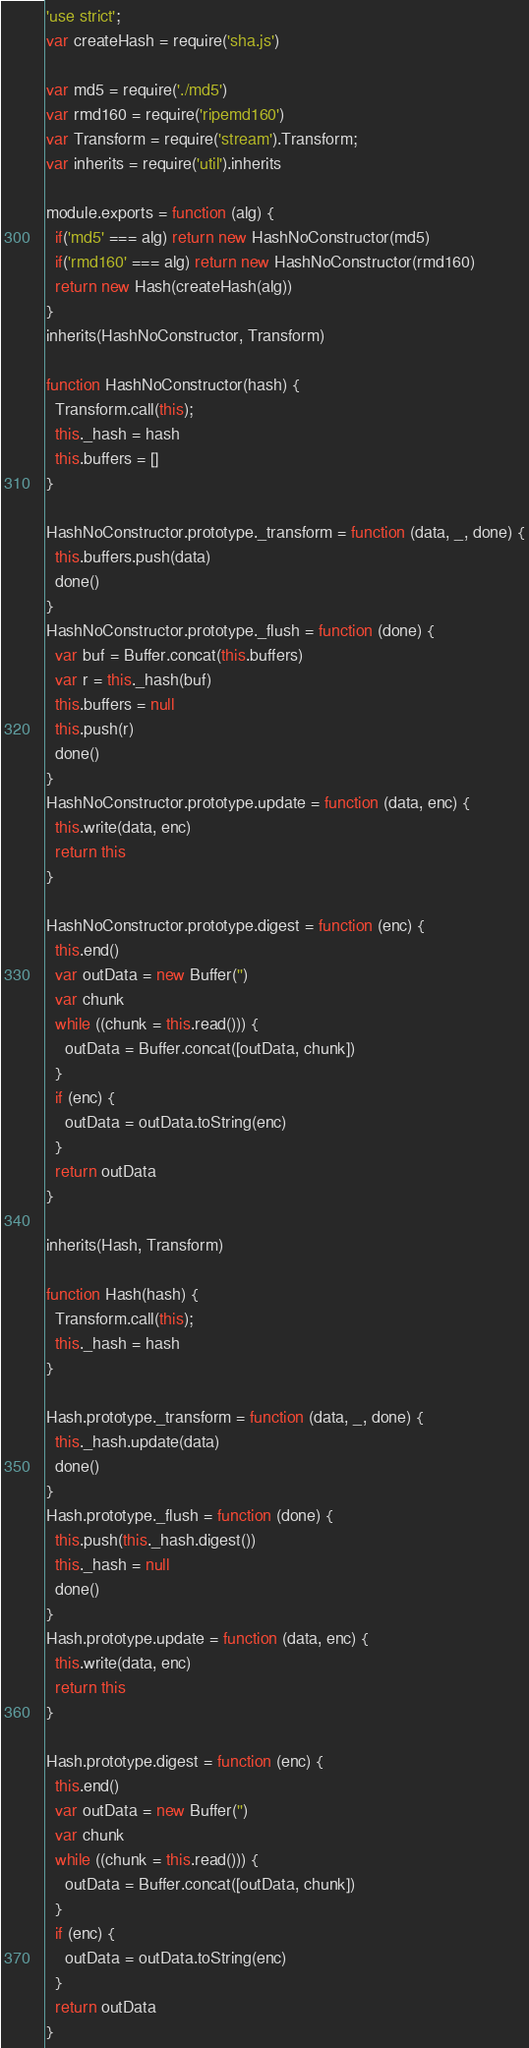Convert code to text. <code><loc_0><loc_0><loc_500><loc_500><_JavaScript_>'use strict';
var createHash = require('sha.js')

var md5 = require('./md5')
var rmd160 = require('ripemd160')
var Transform = require('stream').Transform;
var inherits = require('util').inherits

module.exports = function (alg) {
  if('md5' === alg) return new HashNoConstructor(md5)
  if('rmd160' === alg) return new HashNoConstructor(rmd160)
  return new Hash(createHash(alg))
}
inherits(HashNoConstructor, Transform)

function HashNoConstructor(hash) {
  Transform.call(this);
  this._hash = hash
  this.buffers = []
}

HashNoConstructor.prototype._transform = function (data, _, done) {
  this.buffers.push(data)
  done()
}
HashNoConstructor.prototype._flush = function (done) {
  var buf = Buffer.concat(this.buffers)
  var r = this._hash(buf)
  this.buffers = null
  this.push(r)
  done()
}
HashNoConstructor.prototype.update = function (data, enc) {
  this.write(data, enc)
  return this
}

HashNoConstructor.prototype.digest = function (enc) {
  this.end()
  var outData = new Buffer('')
  var chunk
  while ((chunk = this.read())) {
    outData = Buffer.concat([outData, chunk])
  }
  if (enc) {
    outData = outData.toString(enc)
  }
  return outData
}

inherits(Hash, Transform)

function Hash(hash) {
  Transform.call(this);
  this._hash = hash
}

Hash.prototype._transform = function (data, _, done) {
  this._hash.update(data)
  done()
}
Hash.prototype._flush = function (done) {
  this.push(this._hash.digest())
  this._hash = null
  done()
}
Hash.prototype.update = function (data, enc) {
  this.write(data, enc)
  return this
}

Hash.prototype.digest = function (enc) {
  this.end()
  var outData = new Buffer('')
  var chunk
  while ((chunk = this.read())) {
    outData = Buffer.concat([outData, chunk])
  }
  if (enc) {
    outData = outData.toString(enc)
  }
  return outData
}
</code> 